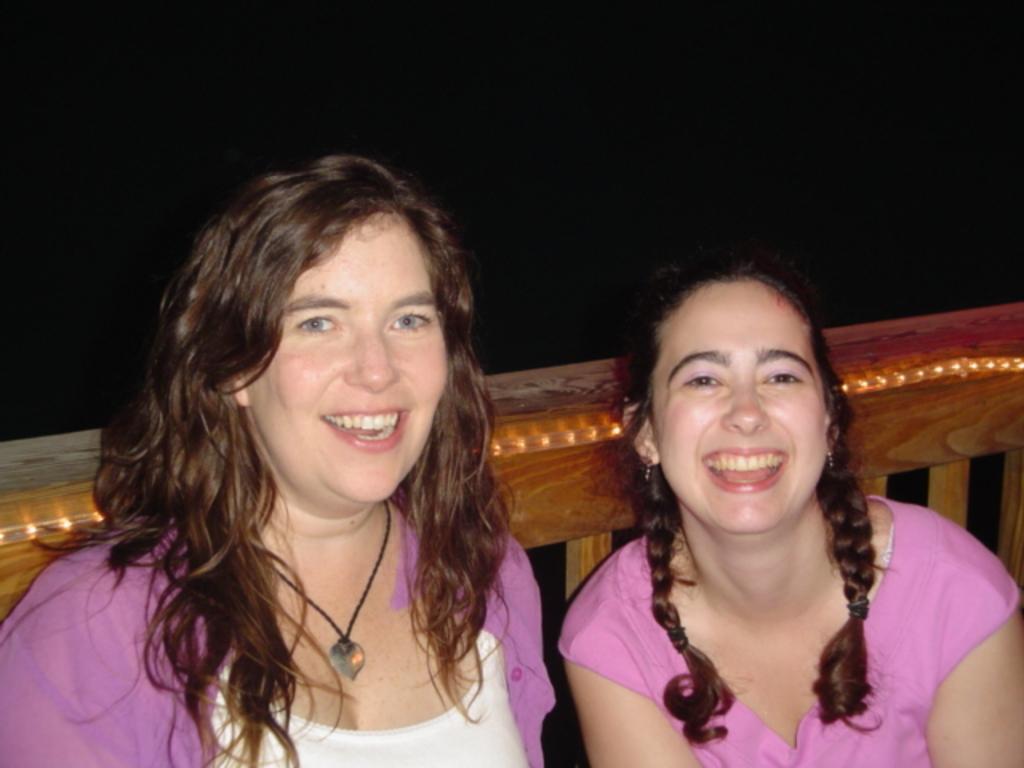How would you summarize this image in a sentence or two? In the picture we can see a woman and a girl sitting beside her and smiling, they are wearing a pink dress and behind them we can see a wooden railing decorated with lights. 